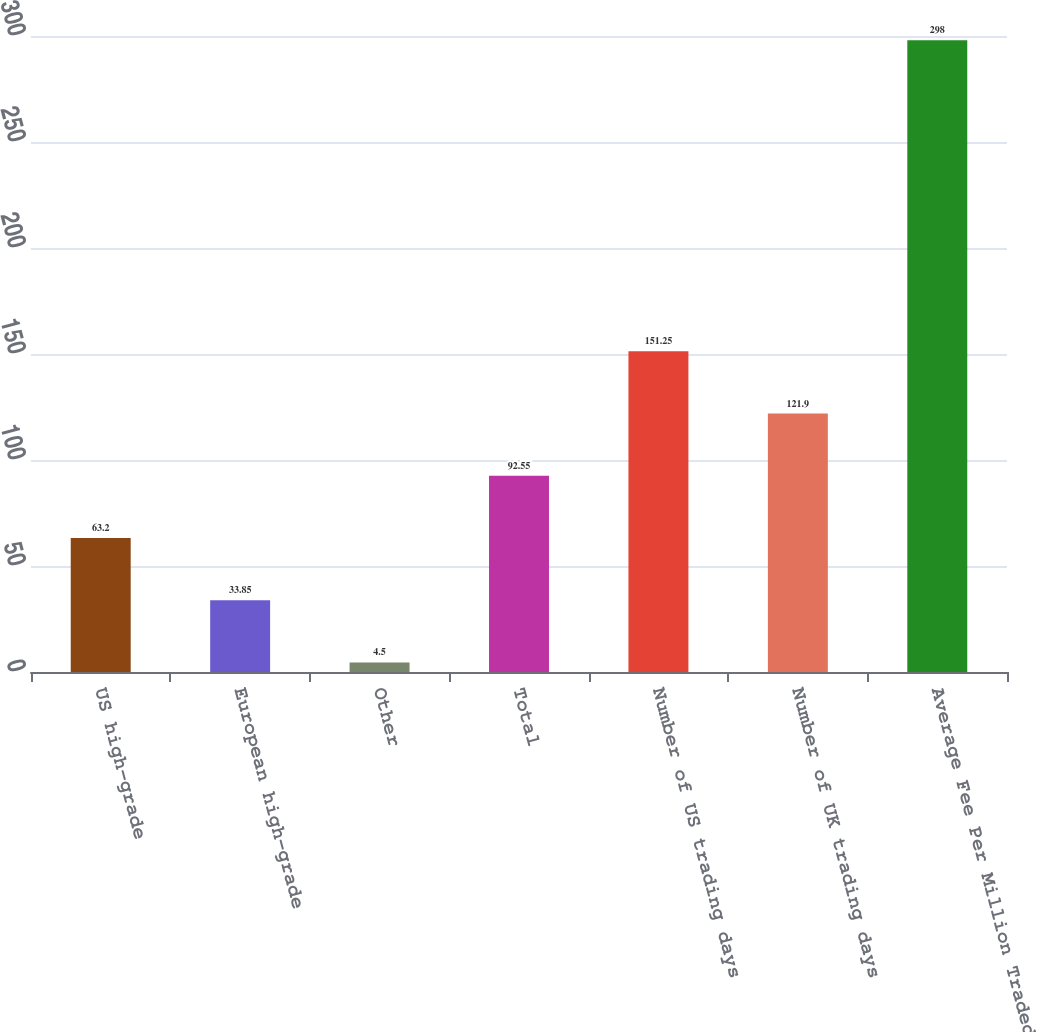<chart> <loc_0><loc_0><loc_500><loc_500><bar_chart><fcel>US high-grade<fcel>European high-grade<fcel>Other<fcel>Total<fcel>Number of US trading days<fcel>Number of UK trading days<fcel>Average Fee Per Million Traded<nl><fcel>63.2<fcel>33.85<fcel>4.5<fcel>92.55<fcel>151.25<fcel>121.9<fcel>298<nl></chart> 